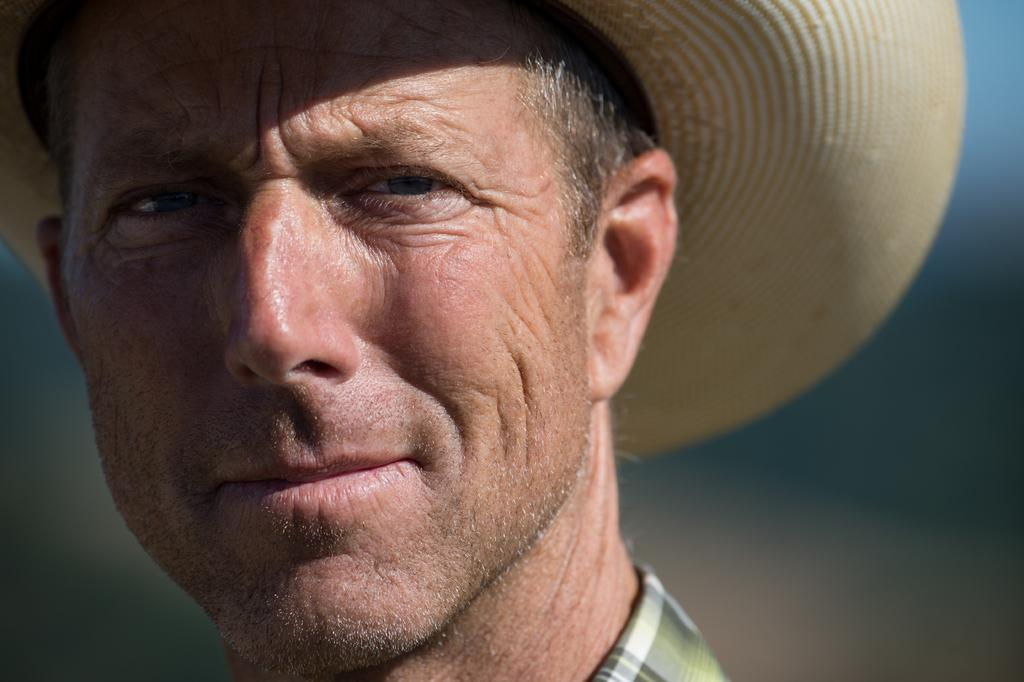Who is present in the image? There is a man in the image. What is the man wearing on his head? The man is wearing a hat. Can you describe the background of the image? The background of the image is blurred. How many rocks can be seen in the man's mouth in the image? There are no rocks visible in the man's mouth in the image. 